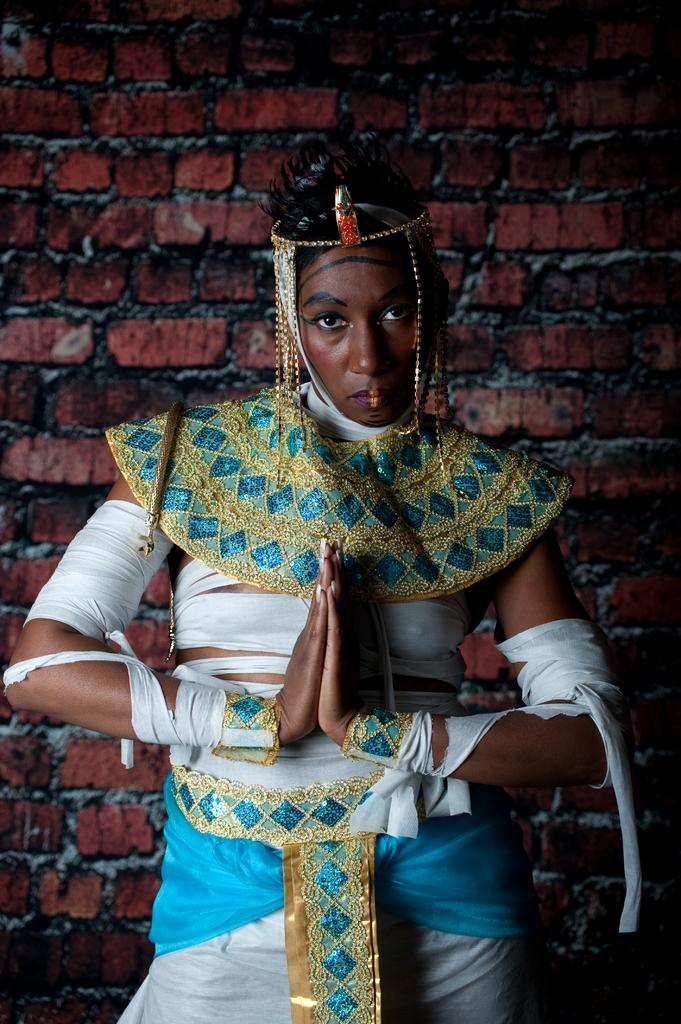Who is present in the image? There is a woman in the image. What is the woman wearing? The woman is wearing a costume. What is the woman doing in the image? The woman is watching something. What can be seen in the background of the image? There is a brick wall in the background of the image. What type of throne is the woman sitting on in the image? There is no throne present in the image; the woman is standing and watching something. What is the mist like in the image? There is no mention of mist in the image; it is not present. 